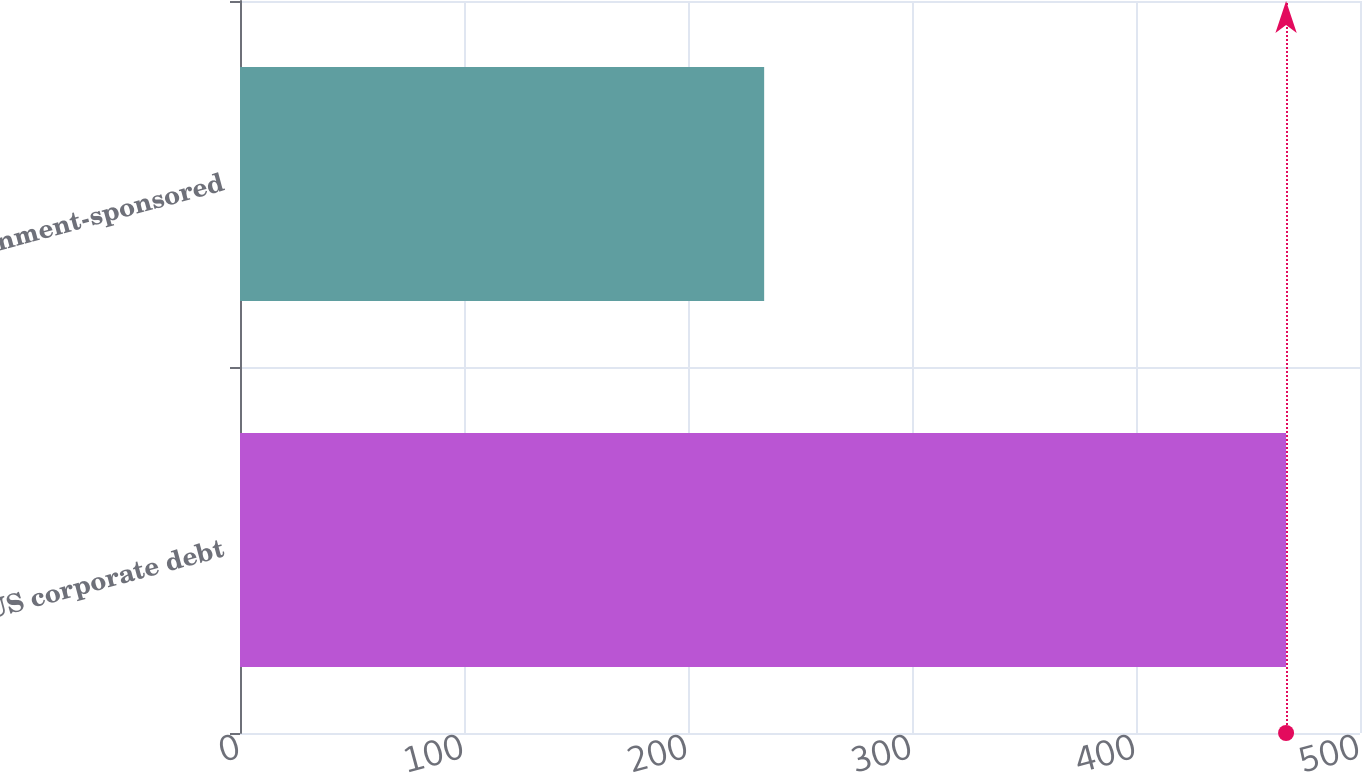<chart> <loc_0><loc_0><loc_500><loc_500><bar_chart><fcel>US corporate debt<fcel>Government-sponsored<nl><fcel>467<fcel>234<nl></chart> 